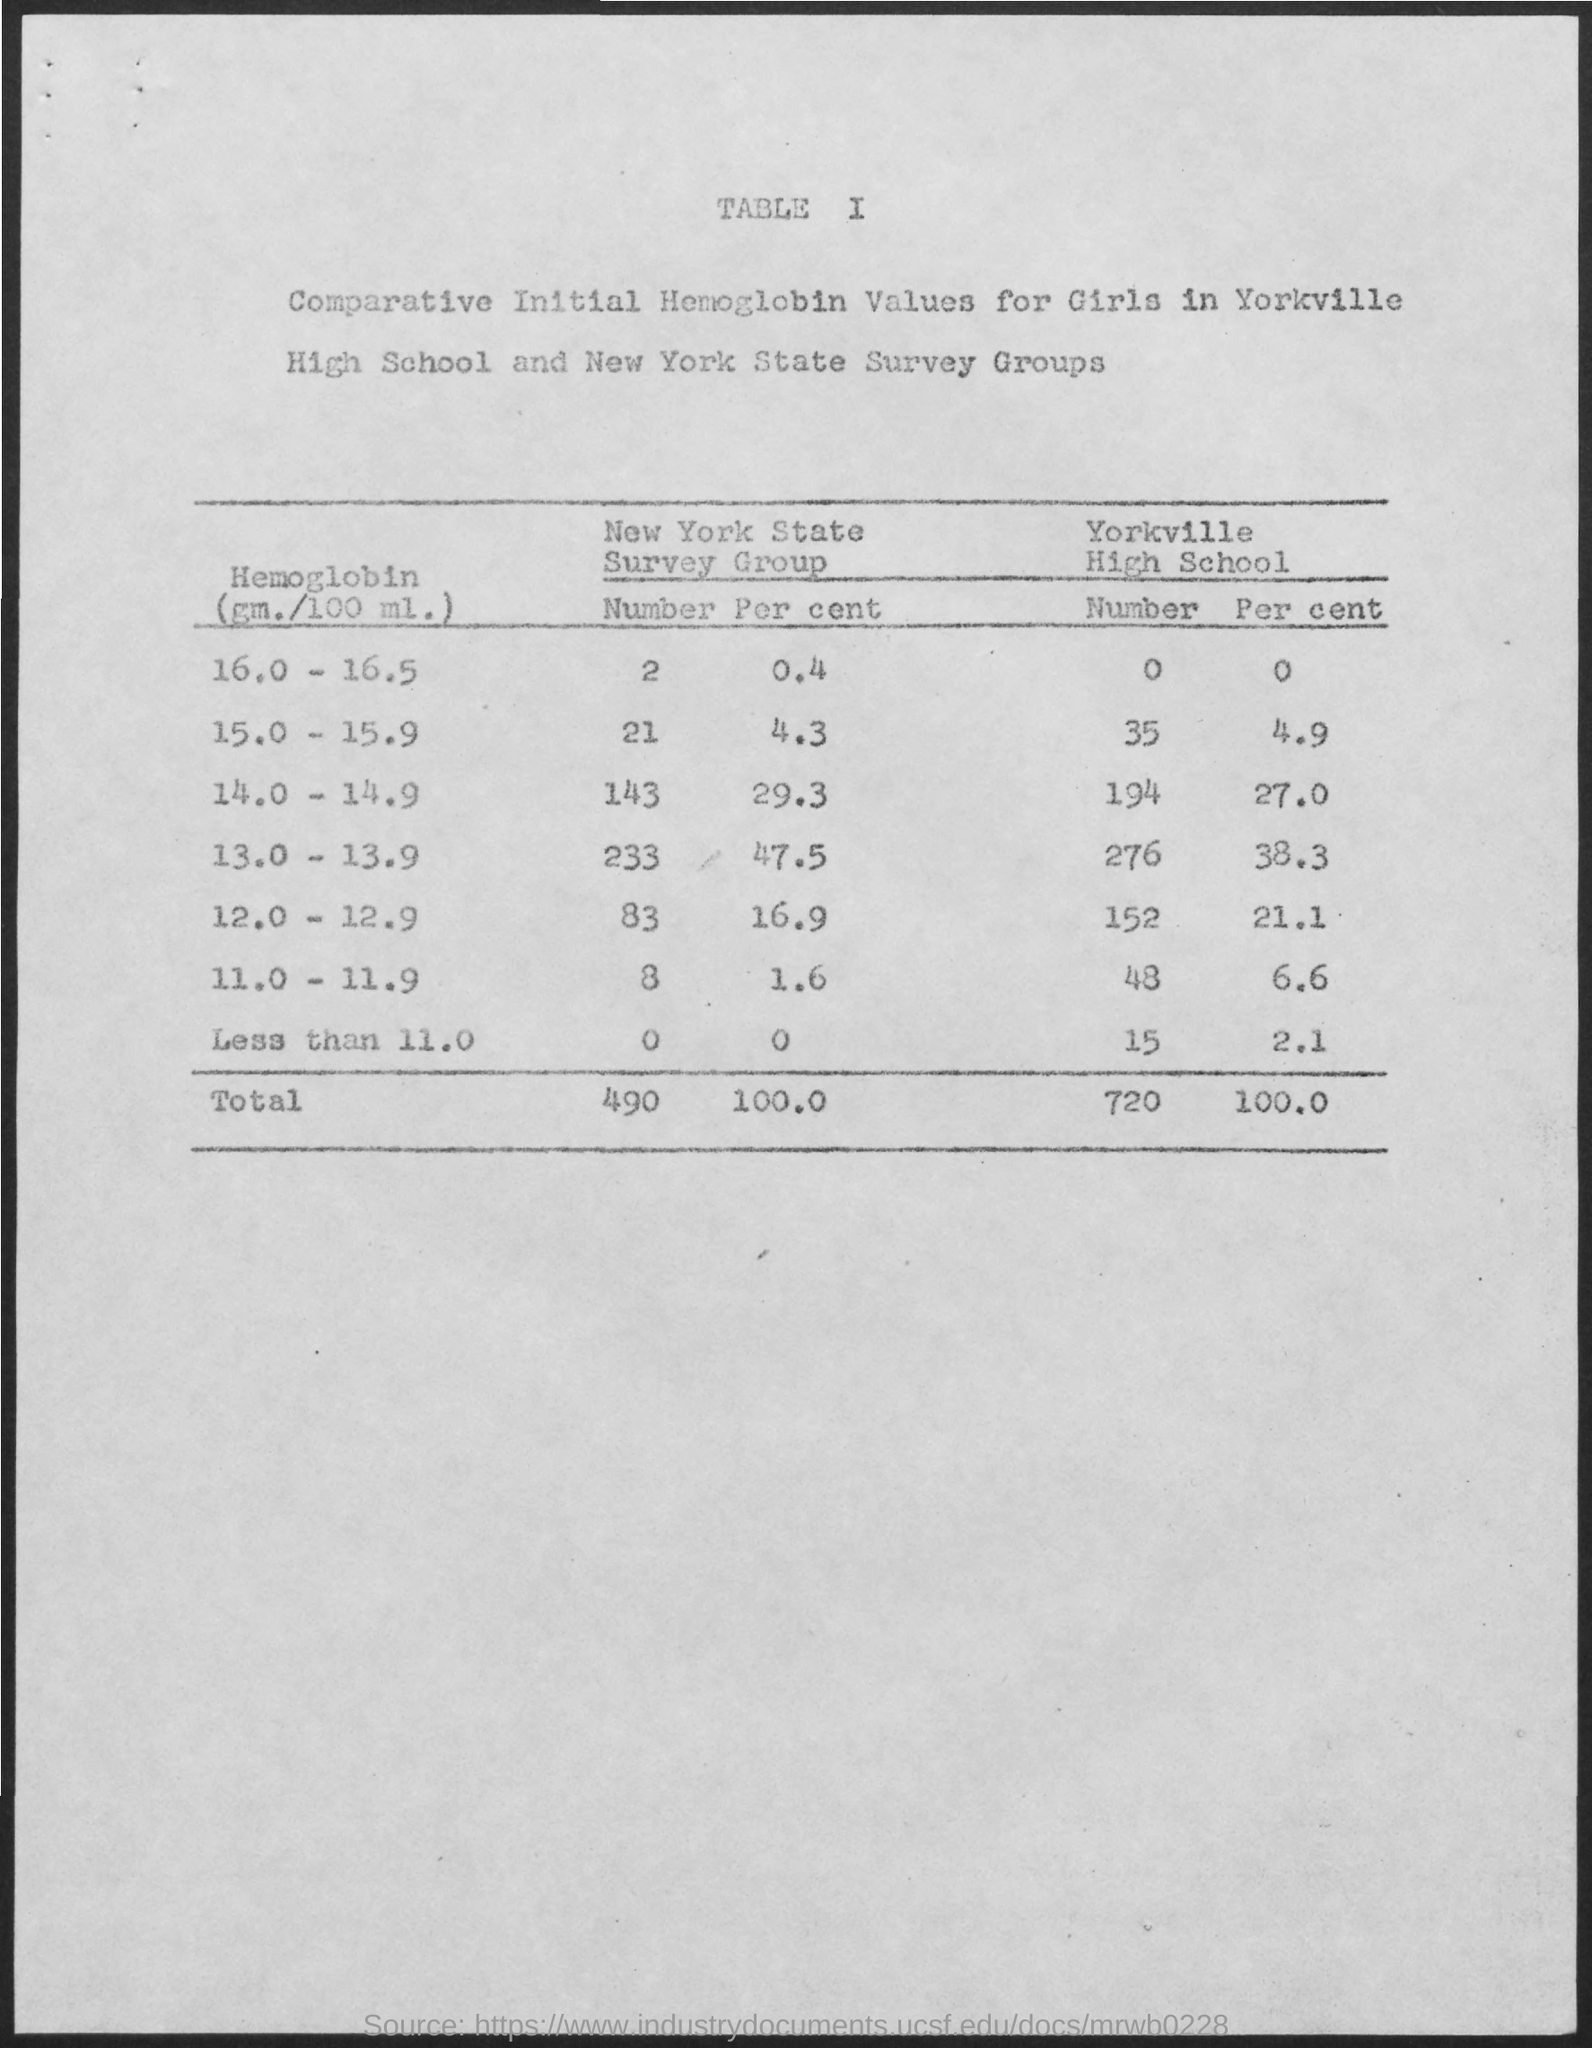Indicate a few pertinent items in this graphic. The total number of members in the New York State Survey Group is 490. 